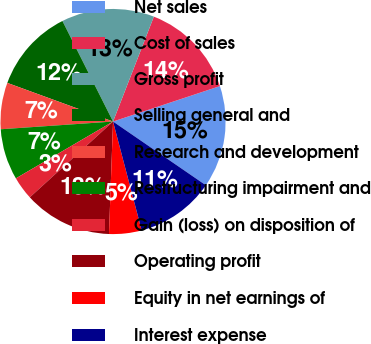Convert chart. <chart><loc_0><loc_0><loc_500><loc_500><pie_chart><fcel>Net sales<fcel>Cost of sales<fcel>Gross profit<fcel>Selling general and<fcel>Research and development<fcel>Restructuring impairment and<fcel>Gain (loss) on disposition of<fcel>Operating profit<fcel>Equity in net earnings of<fcel>Interest expense<nl><fcel>14.67%<fcel>14.0%<fcel>13.33%<fcel>12.0%<fcel>6.67%<fcel>7.33%<fcel>3.33%<fcel>12.67%<fcel>4.67%<fcel>11.33%<nl></chart> 